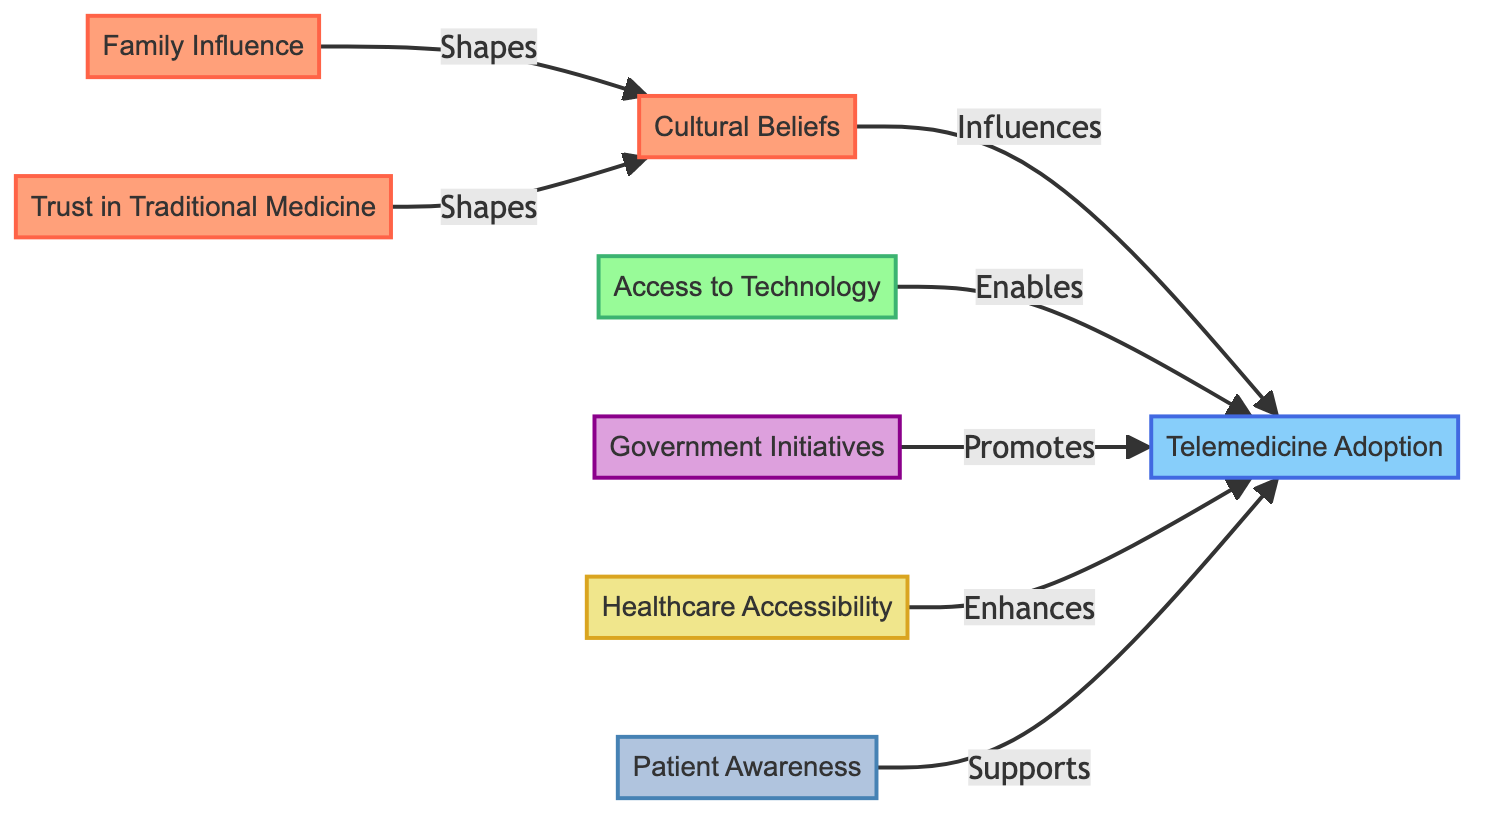What are the factors influencing cultural beliefs? Cultural beliefs are shaped by both family influence and trust in traditional medicine, which are represented as edges leading to the cultural beliefs node.
Answer: Family Influence and Trust in Traditional Medicine How many nodes are in the diagram? The diagram contains eight distinct nodes: Cultural Beliefs, Telemedicine Adoption, Family Influence, Trust in Traditional Medicine, Access to Technology, Government Initiatives, Healthcare Accessibility, and Patient Awareness.
Answer: 8 Which node promotes telemedicine adoption? The node "Government Initiatives" is directly connected to the "Telemedicine Adoption" node with the label "Promotes," indicating that it contributes positively to telemedicine adoption.
Answer: Government Initiatives What influences telemedicine adoption? Telemedicine adoption is influenced by cultural beliefs, access to technology, government initiatives, healthcare accessibility, and patient awareness, as indicated by the arrows pointing towards the telemedicine adoption node.
Answer: Cultural Beliefs, Access to Technology, Government Initiatives, Healthcare Accessibility, Patient Awareness How many edges lead to the telemedicine adoption node? There are five edges leading to the "Telemedicine Adoption" node, each indicating different factors influencing its adoption.
Answer: 5 Which factors enable the adoption of telemedicine? The diagram specifies that "Access to Technology" enables the adoption of telemedicine, indicated by a direct link labeled "Enables" pointing towards the telemedicine adoption node.
Answer: Access to Technology What shape does family influence take when it connects to cultural beliefs? The relationship between "Family Influence" and "Cultural Beliefs" is represented as a directed edge labeled "Shapes," indicating a formative influence on cultural beliefs.
Answer: Shapes Which aspect enhances telemedicine adoption? "Healthcare Accessibility" enhances telemedicine adoption, as represented by the directed edge from "Healthcare Accessibility" to "Telemedicine Adoption" with the label "Enhances."
Answer: Healthcare Accessibility What type of diagram is being analyzed? The type of diagram being analyzed is a flowchart, specifically a Biomedical Diagram depicting the influences on telemedicine adoption.
Answer: Flowchart 